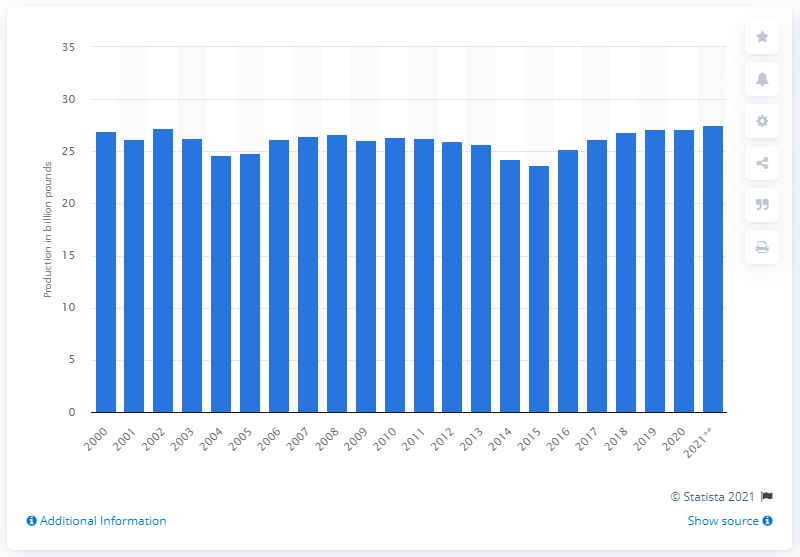Draw attention to some important aspects in this diagram. Last year, the beef production in the United States was 27.15 million head. The estimated beef production in the United States for the year 2021 is projected to be 27.54. 